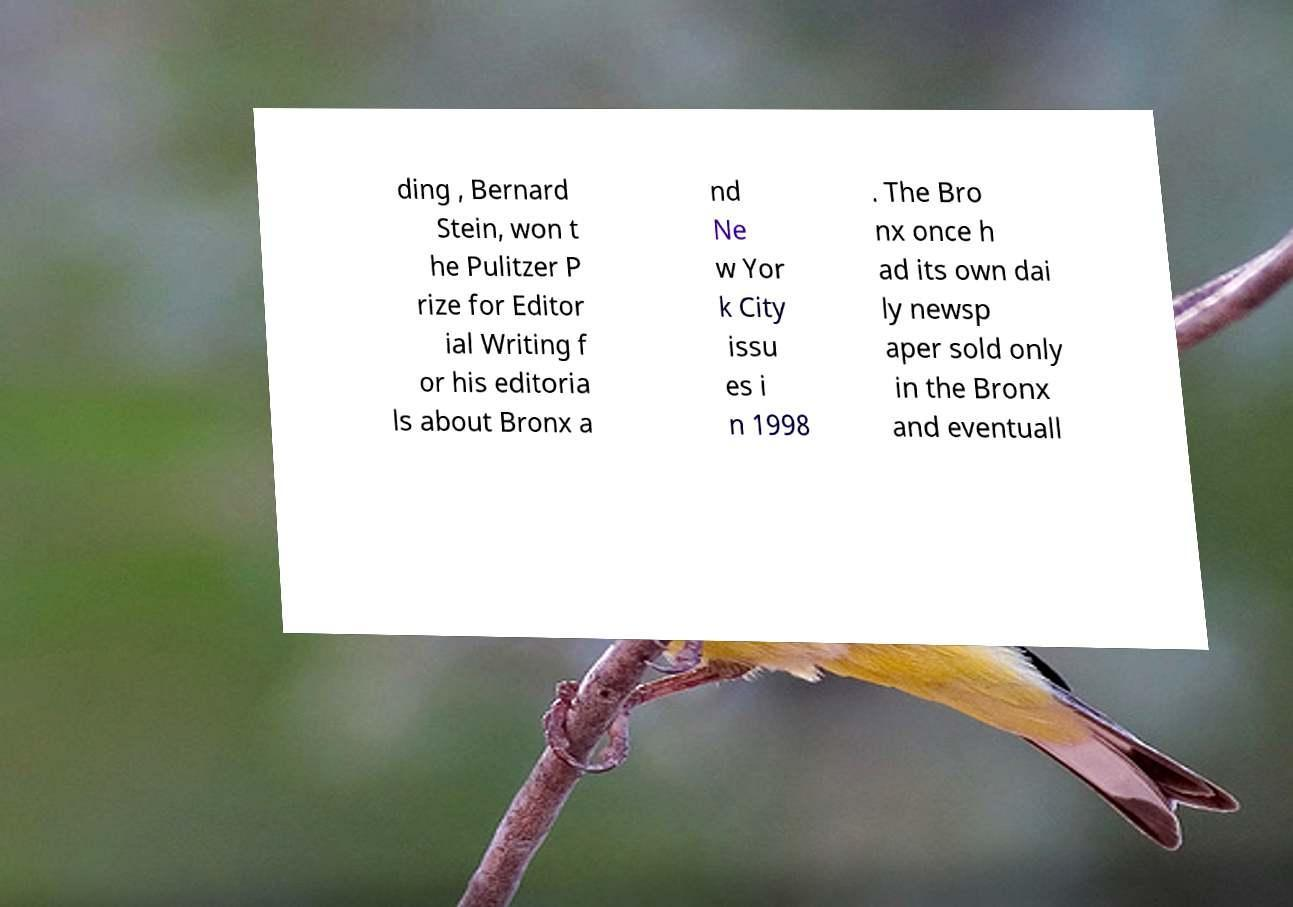For documentation purposes, I need the text within this image transcribed. Could you provide that? ding , Bernard Stein, won t he Pulitzer P rize for Editor ial Writing f or his editoria ls about Bronx a nd Ne w Yor k City issu es i n 1998 . The Bro nx once h ad its own dai ly newsp aper sold only in the Bronx and eventuall 